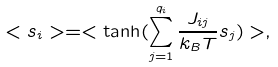Convert formula to latex. <formula><loc_0><loc_0><loc_500><loc_500>< s _ { i } > = < \tanh ( \sum _ { j = 1 } ^ { q _ { i } } \frac { J _ { i j } } { k _ { B } T } s _ { j } ) > ,</formula> 